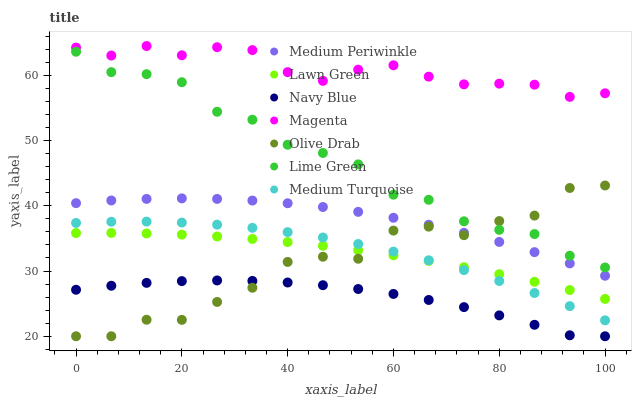Does Navy Blue have the minimum area under the curve?
Answer yes or no. Yes. Does Magenta have the maximum area under the curve?
Answer yes or no. Yes. Does Medium Periwinkle have the minimum area under the curve?
Answer yes or no. No. Does Medium Periwinkle have the maximum area under the curve?
Answer yes or no. No. Is Lawn Green the smoothest?
Answer yes or no. Yes. Is Olive Drab the roughest?
Answer yes or no. Yes. Is Navy Blue the smoothest?
Answer yes or no. No. Is Navy Blue the roughest?
Answer yes or no. No. Does Navy Blue have the lowest value?
Answer yes or no. Yes. Does Medium Periwinkle have the lowest value?
Answer yes or no. No. Does Magenta have the highest value?
Answer yes or no. Yes. Does Medium Periwinkle have the highest value?
Answer yes or no. No. Is Navy Blue less than Medium Periwinkle?
Answer yes or no. Yes. Is Lawn Green greater than Navy Blue?
Answer yes or no. Yes. Does Navy Blue intersect Olive Drab?
Answer yes or no. Yes. Is Navy Blue less than Olive Drab?
Answer yes or no. No. Is Navy Blue greater than Olive Drab?
Answer yes or no. No. Does Navy Blue intersect Medium Periwinkle?
Answer yes or no. No. 